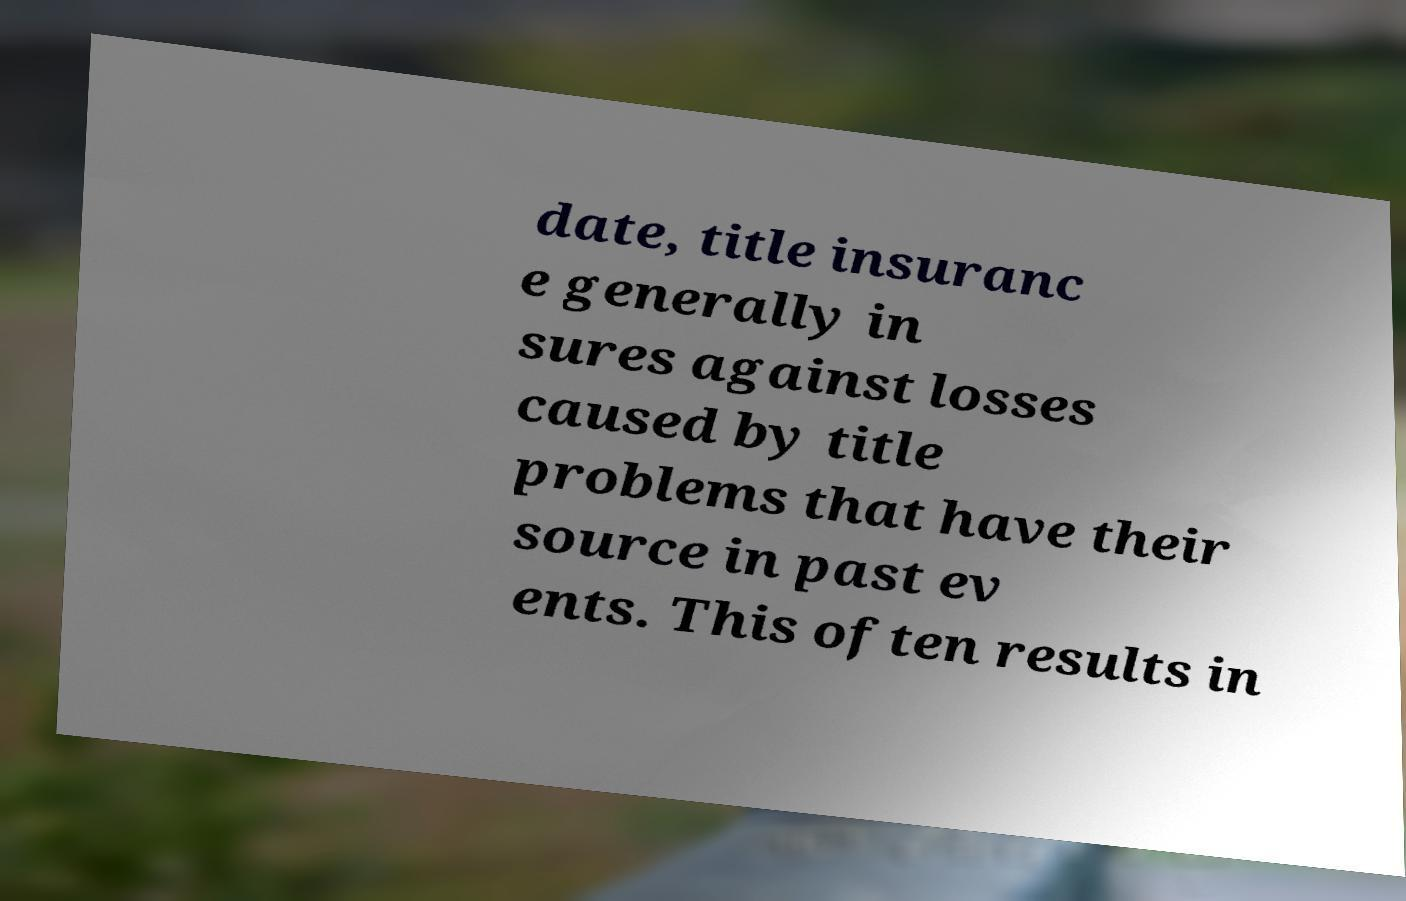Can you accurately transcribe the text from the provided image for me? date, title insuranc e generally in sures against losses caused by title problems that have their source in past ev ents. This often results in 